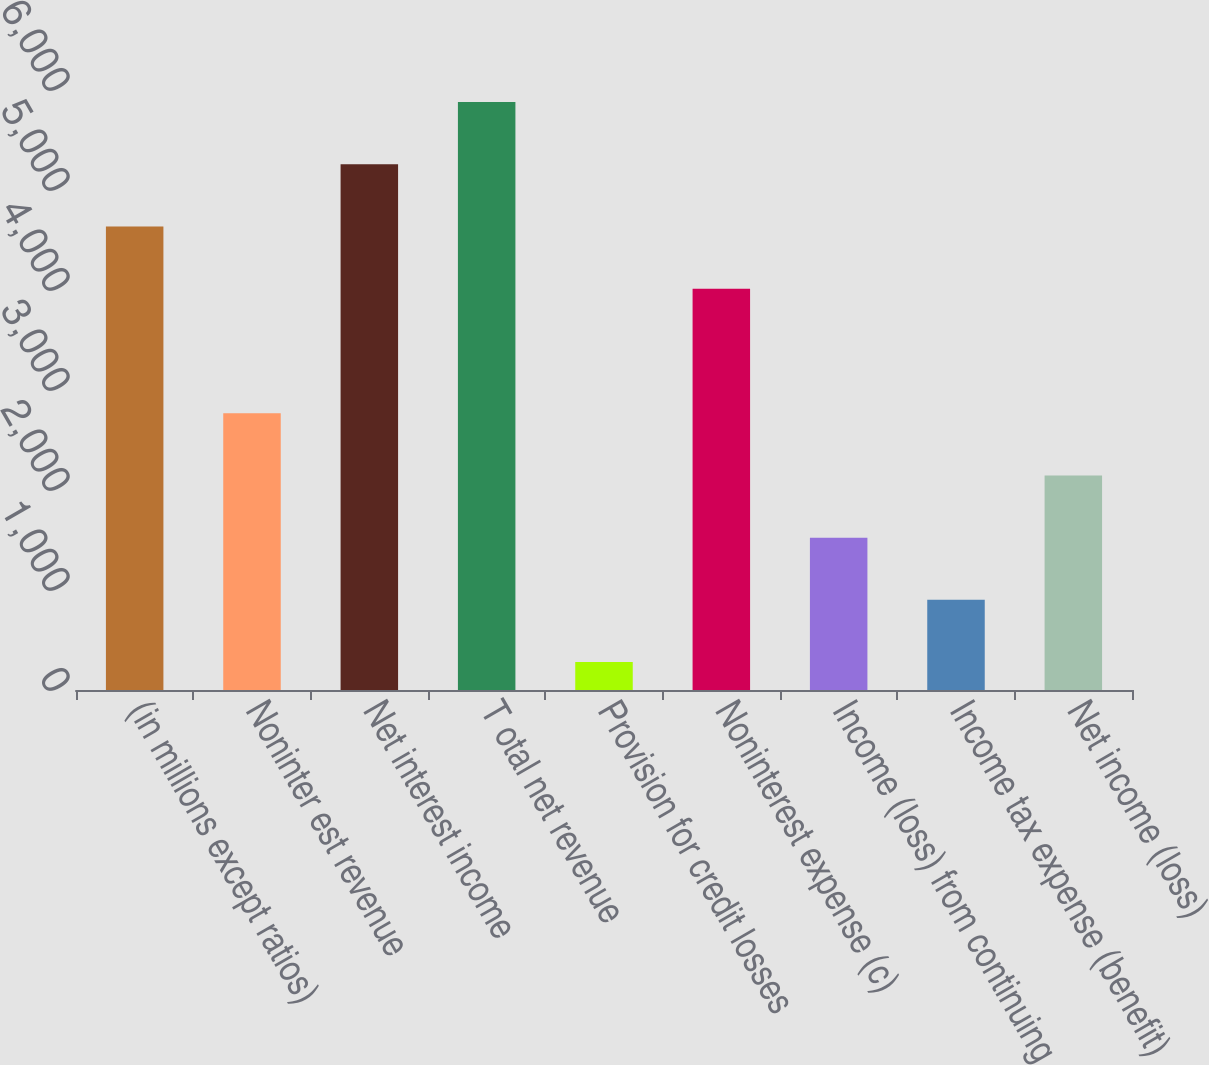Convert chart. <chart><loc_0><loc_0><loc_500><loc_500><bar_chart><fcel>(in millions except ratios)<fcel>Noninter est revenue<fcel>Net interest income<fcel>T otal net revenue<fcel>Provision for credit losses<fcel>Noninterest expense (c)<fcel>Income (loss) from continuing<fcel>Income tax expense (benefit)<fcel>Net income (loss)<nl><fcel>4635.1<fcel>2768.2<fcel>5257.4<fcel>5879.7<fcel>279<fcel>4012.8<fcel>1523.6<fcel>901.3<fcel>2145.9<nl></chart> 